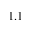<formula> <loc_0><loc_0><loc_500><loc_500>1 . 1</formula> 